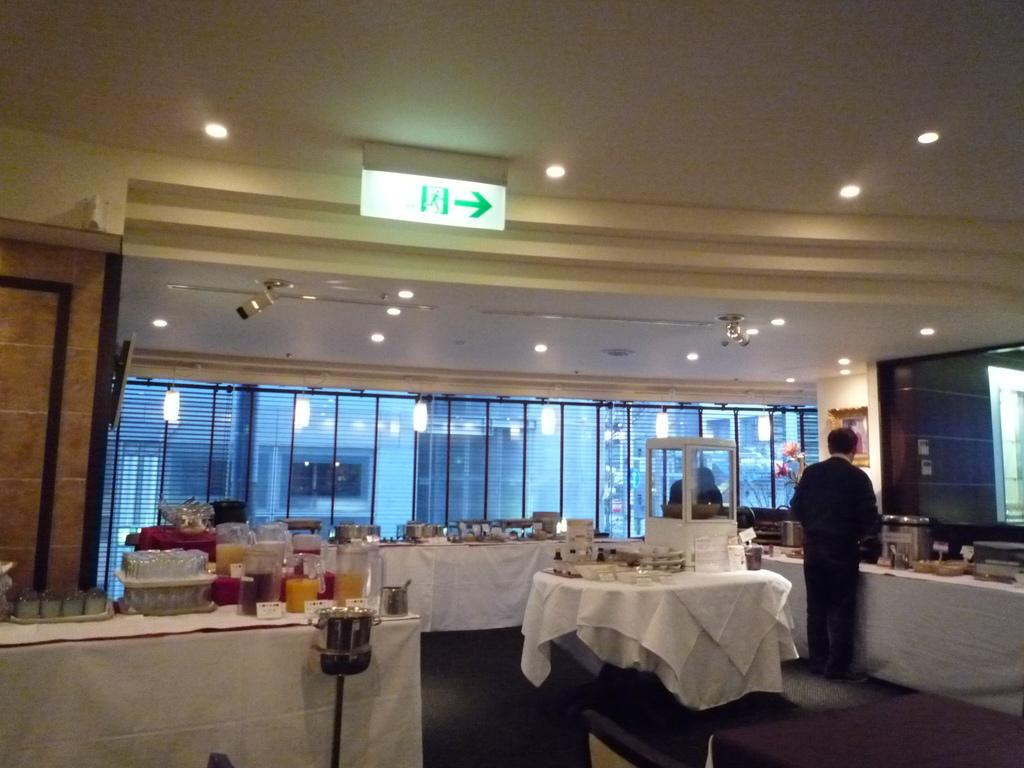What type of space is depicted in the image? There is a room in the image. What can be found on the tables in the room? There are tables with food items in the room. Is there anyone present in the room? Yes, there is a person standing in the room. What can be seen in terms of lighting in the image? There are lights visible in the image. What type of paste is being used by the person in the image? There is no indication of any paste being used in the image; the person is simply standing in the room. 